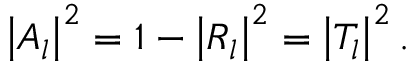Convert formula to latex. <formula><loc_0><loc_0><loc_500><loc_500>\left | A _ { l } \right | ^ { 2 } = 1 - \left | R _ { l } \right | ^ { 2 } = \left | T _ { l } \right | ^ { 2 } .</formula> 